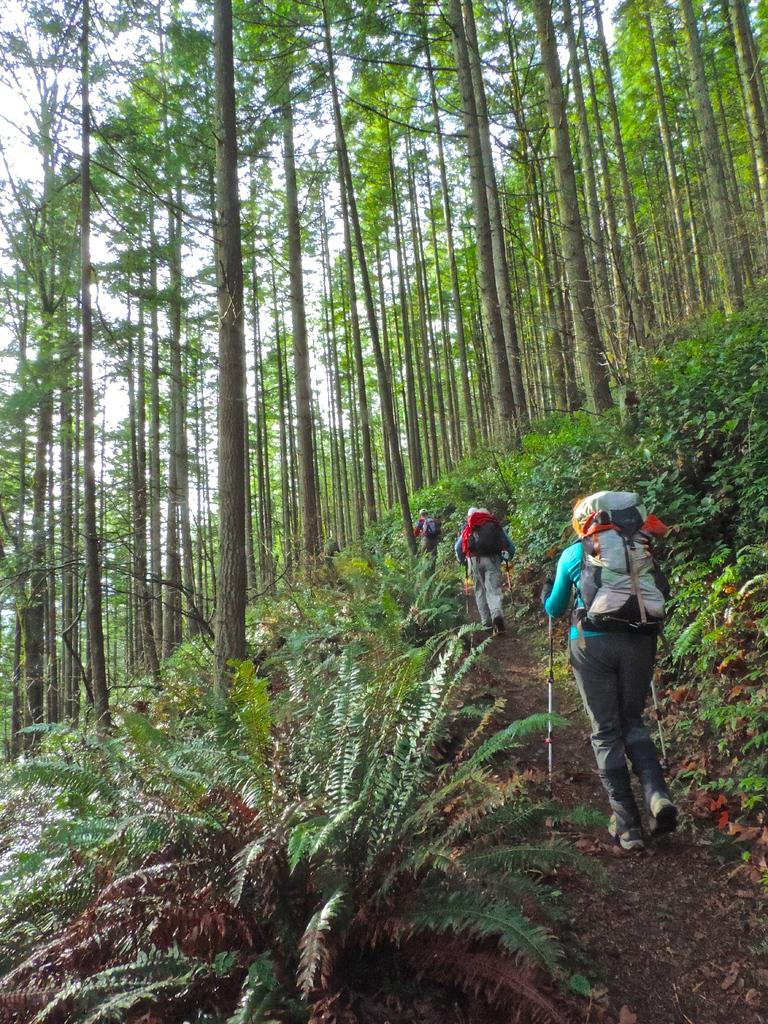What types of vegetation can be seen in the foreground of the picture? There are plants and trees in the foreground of the picture. What activity are the people engaged in? The people are doing tracking in the foreground of the picture. What else can be seen in the foreground of the picture besides the vegetation and people? There are other objects in the foreground of the picture. What is visible in the background of the picture? There are trees in the background of the picture. What is visible at the top of the picture? The sky is visible at the top of the picture. Can you tell me how many dolls are being offered to the people in the picture? There are no dolls or offers present in the image; it features people doing tracking in a natural setting with vegetation and trees. Is there a receipt visible in the picture? There is no receipt present in the image. 